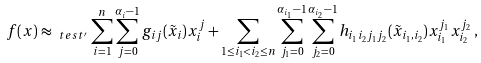Convert formula to latex. <formula><loc_0><loc_0><loc_500><loc_500>f ( x ) \approx _ { \ t e s t ^ { \prime } } \sum _ { i = 1 } ^ { n } \sum _ { j = 0 } ^ { \alpha _ { i } - 1 } g _ { i j } ( \tilde { x } _ { i } ) x _ { i } ^ { j } + \sum _ { 1 \leq i _ { 1 } < i _ { 2 } \leq n } \sum _ { j _ { 1 } = 0 } ^ { \alpha _ { i _ { 1 } } - 1 } \sum _ { j _ { 2 } = 0 } ^ { \alpha _ { i _ { 2 } } - 1 } h _ { i _ { 1 } i _ { 2 } j _ { 1 } j _ { 2 } } ( \tilde { x } _ { i _ { 1 } , i _ { 2 } } ) x _ { i _ { 1 } } ^ { j _ { 1 } } x _ { i _ { 2 } } ^ { j _ { 2 } } \, ,</formula> 